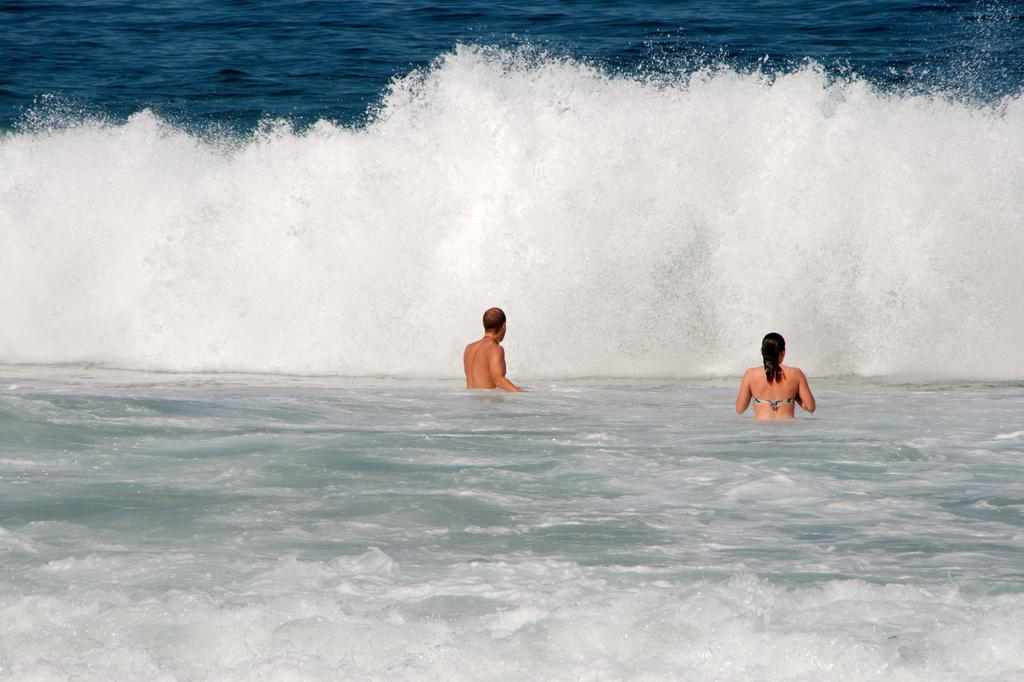How many people are in the image? There are two persons in the image. What are the two persons doing in the image? The two persons are standing in water. What type of horses can be seen swimming alongside the persons in the image? There are no horses present in the image; it only features two persons standing in water. 